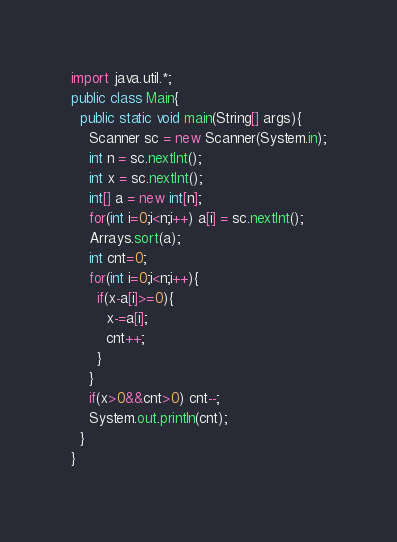Convert code to text. <code><loc_0><loc_0><loc_500><loc_500><_Java_>import java.util.*;
public class Main{
  public static void main(String[] args){
    Scanner sc = new Scanner(System.in);
    int n = sc.nextInt();
    int x = sc.nextInt();
    int[] a = new int[n];
    for(int i=0;i<n;i++) a[i] = sc.nextInt();
    Arrays.sort(a);
    int cnt=0;
    for(int i=0;i<n;i++){
      if(x-a[i]>=0){
        x-=a[i];
        cnt++;
      }
    }
    if(x>0&&cnt>0) cnt--;
    System.out.println(cnt);
  }
}</code> 